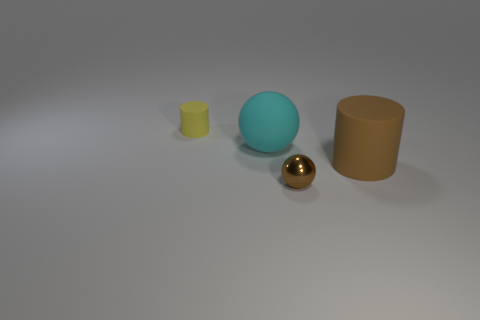Does the ball in front of the matte ball have the same size as the cyan matte ball? The golden ball in front of the larger cyan matte ball appears to be smaller in size when compared directly. It's visually evident that their sizes are not the same; the cyan ball is noticeably larger. 